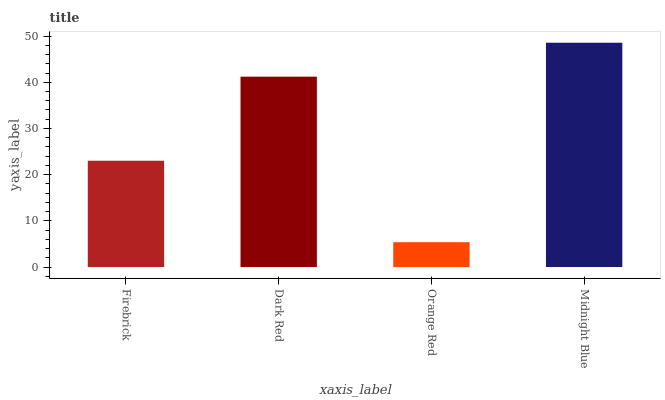Is Orange Red the minimum?
Answer yes or no. Yes. Is Midnight Blue the maximum?
Answer yes or no. Yes. Is Dark Red the minimum?
Answer yes or no. No. Is Dark Red the maximum?
Answer yes or no. No. Is Dark Red greater than Firebrick?
Answer yes or no. Yes. Is Firebrick less than Dark Red?
Answer yes or no. Yes. Is Firebrick greater than Dark Red?
Answer yes or no. No. Is Dark Red less than Firebrick?
Answer yes or no. No. Is Dark Red the high median?
Answer yes or no. Yes. Is Firebrick the low median?
Answer yes or no. Yes. Is Orange Red the high median?
Answer yes or no. No. Is Midnight Blue the low median?
Answer yes or no. No. 